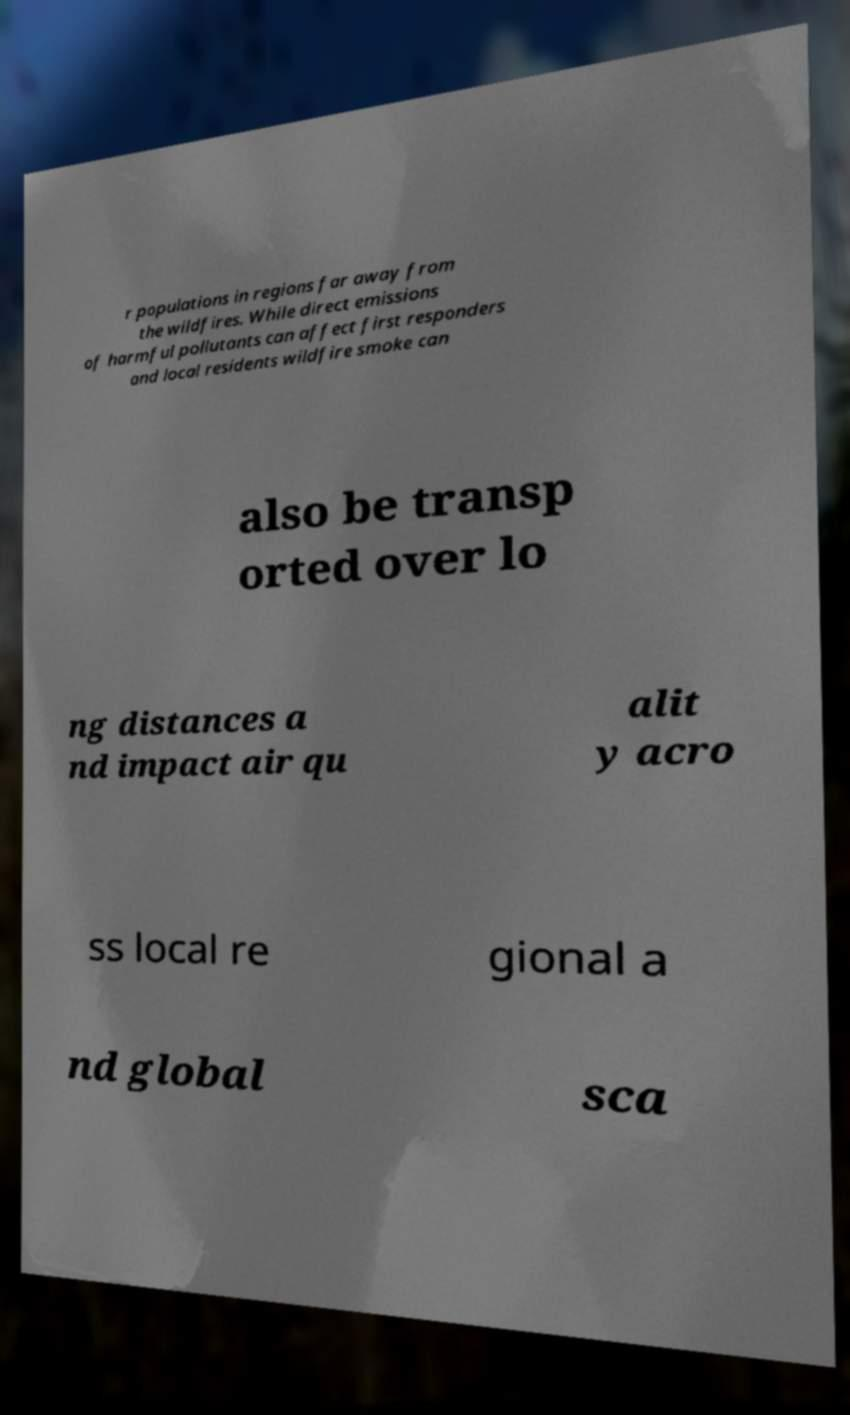I need the written content from this picture converted into text. Can you do that? r populations in regions far away from the wildfires. While direct emissions of harmful pollutants can affect first responders and local residents wildfire smoke can also be transp orted over lo ng distances a nd impact air qu alit y acro ss local re gional a nd global sca 